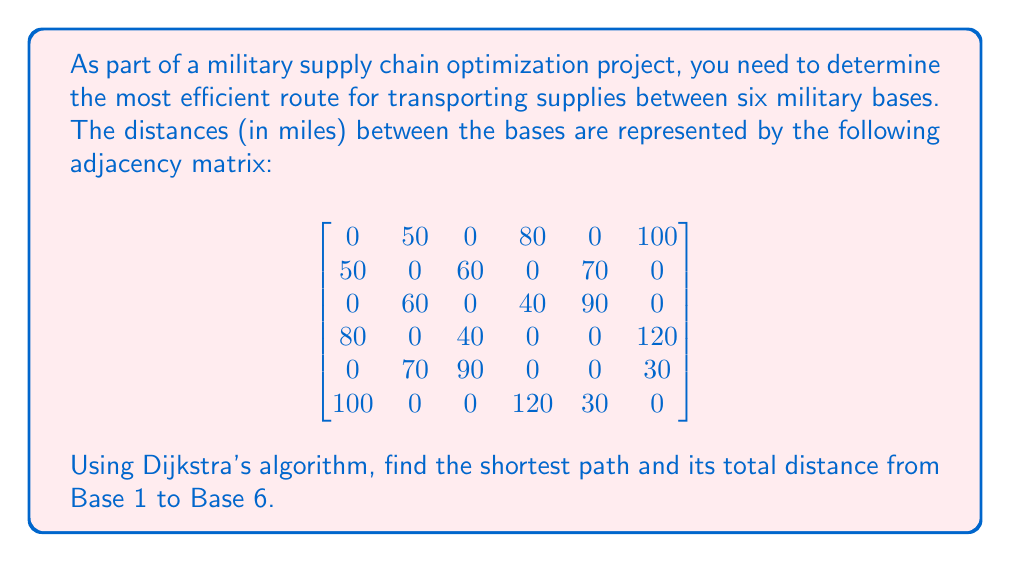Help me with this question. To solve this problem, we'll apply Dijkstra's algorithm to find the shortest path from Base 1 to Base 6. Let's follow these steps:

1) Initialize:
   - Set distance to Base 1 (source) as 0
   - Set distances to all other bases as infinity
   - Mark all bases as unvisited

2) For the current base (starting with Base 1), consider all unvisited neighbors and calculate their tentative distances.

3) When we're done considering all neighbors of the current base, mark it as visited. A visited base will not be checked again.

4) If Base 6 has been marked visited, we're done. Otherwise, select the unvisited base with the smallest tentative distance and set it as the new current base. Go back to step 2.

Let's apply the algorithm:

Iteration 1 (Base 1):
- Update distances: Base 2 (50), Base 4 (80), Base 6 (100)
- Mark Base 1 as visited

Iteration 2 (Base 2):
- Update distances: Base 3 (110), Base 5 (120)
- Mark Base 2 as visited

Iteration 3 (Base 4):
- Update distance: Base 3 (120)
- Mark Base 4 as visited

Iteration 4 (Base 6):
- No updates
- Mark Base 6 as visited

The algorithm terminates as we've reached Base 6.

The shortest path is: Base 1 → Base 6
The total distance is 100 miles.
Answer: The shortest path from Base 1 to Base 6 is Base 1 → Base 6, with a total distance of 100 miles. 